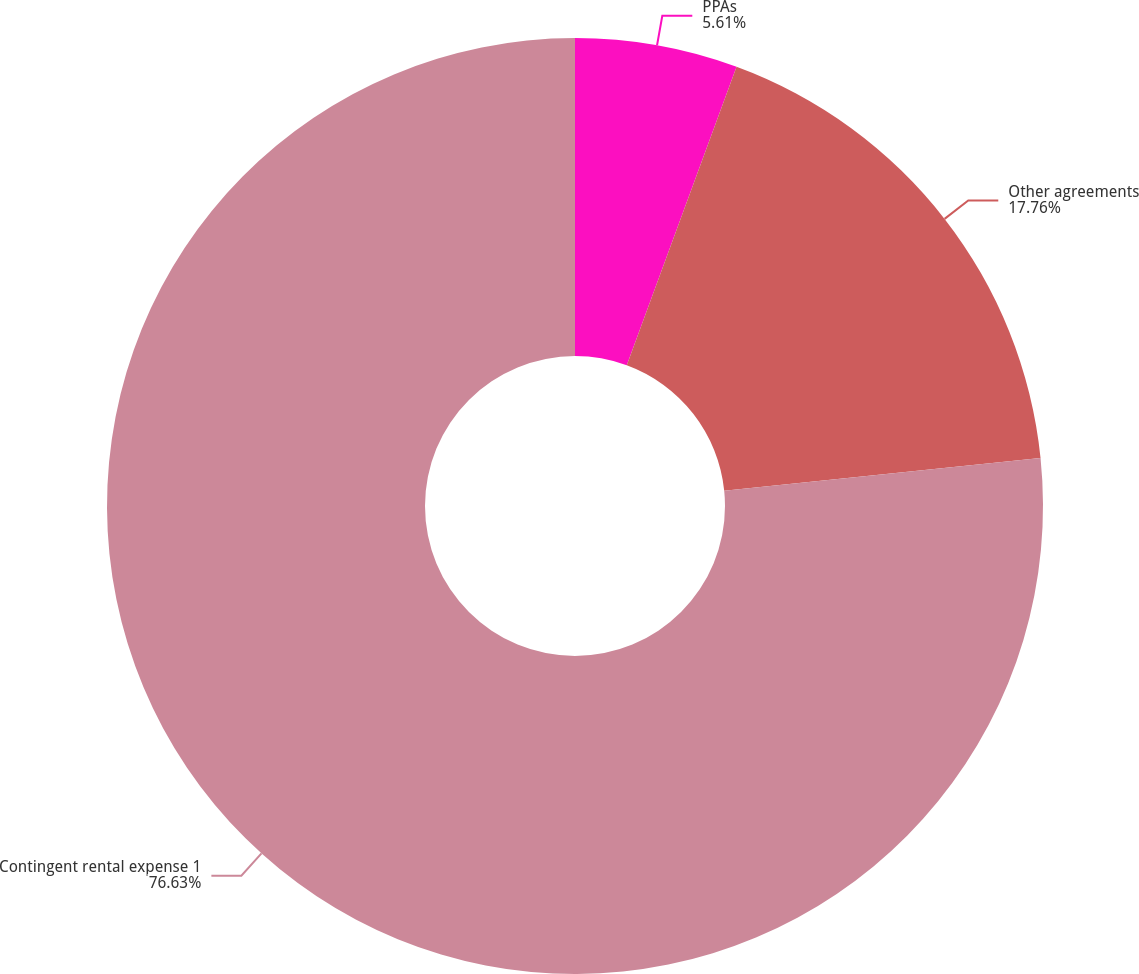Convert chart. <chart><loc_0><loc_0><loc_500><loc_500><pie_chart><fcel>PPAs<fcel>Other agreements<fcel>Contingent rental expense 1<nl><fcel>5.61%<fcel>17.76%<fcel>76.64%<nl></chart> 